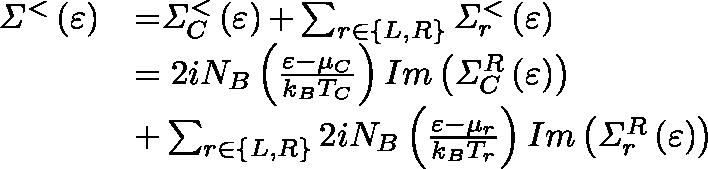Convert formula to latex. <formula><loc_0><loc_0><loc_500><loc_500>\begin{array} { l l } { { \Sigma } ^ { < } \left ( \varepsilon \right ) } & { { = } { \Sigma } _ { C } ^ { < } \left ( \varepsilon \right ) { + } \sum _ { r { \in } \left \{ L , R \right \} } { { \Sigma } _ { r } ^ { < } \left ( \varepsilon \right ) } } \\ & { { = 2 } i N _ { B } \left ( \frac { \varepsilon - \mu _ { C } } { k _ { B } T _ { C } } \right ) I m \left ( { \Sigma } _ { C } ^ { R } \left ( \varepsilon \right ) \right ) } \\ & { { + } \sum _ { r { \in } \left \{ L , R \right \} } { { 2 } i N _ { B } \left ( \frac { \varepsilon { - } { \mu } _ { r } } { k _ { B } T _ { r } } \right ) I m \left ( { \Sigma } _ { r } ^ { R } \left ( \varepsilon \right ) \right ) } } \end{array}</formula> 